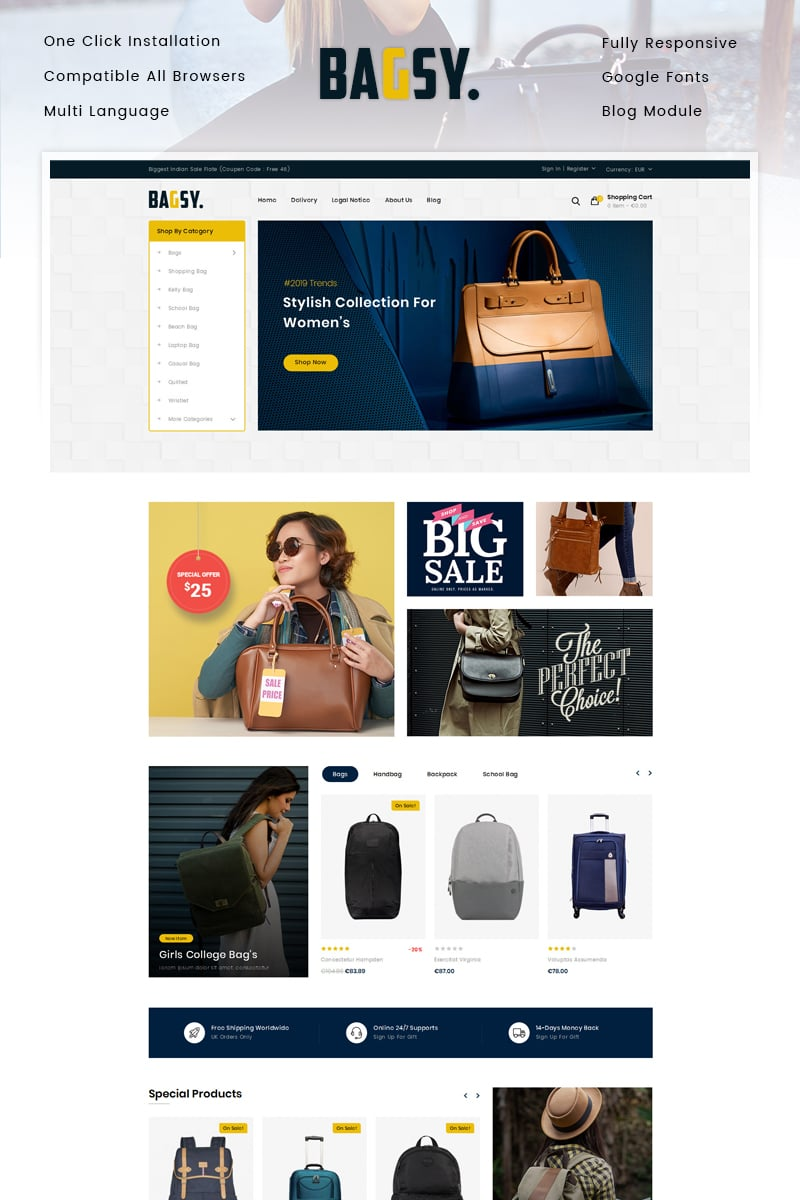How does the website use pricing strategies to appeal to its audience? The website strategically displays pricing details with contrasting color tags that stand out against the background, making them very noticeable. Notable phrases like 'Special Offer', 'BIG SALE', and discounted prices are prominently featured, which can be very appealing to consumers looking for fashion deals. This pricing strategy not only emphasizes affordability but also suggests a transient opportunity to secure high-fashion items at reduced prices, driving quick decision-making among bargain-conscious shoppers. 